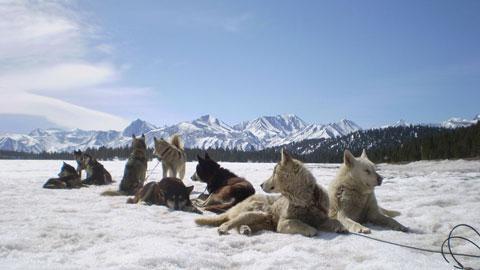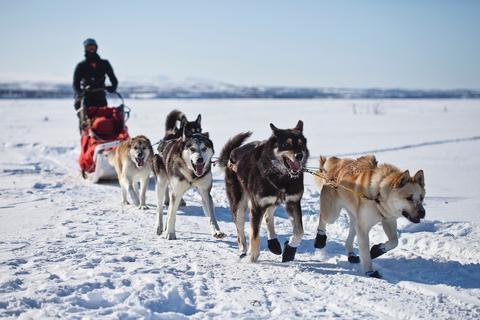The first image is the image on the left, the second image is the image on the right. Considering the images on both sides, is "In one image, a fraction of the dogs in a sled team headed toward the camera are wearing black booties." valid? Answer yes or no. Yes. The first image is the image on the left, the second image is the image on the right. Considering the images on both sides, is "None of the dogs are wearing gloves." valid? Answer yes or no. No. 